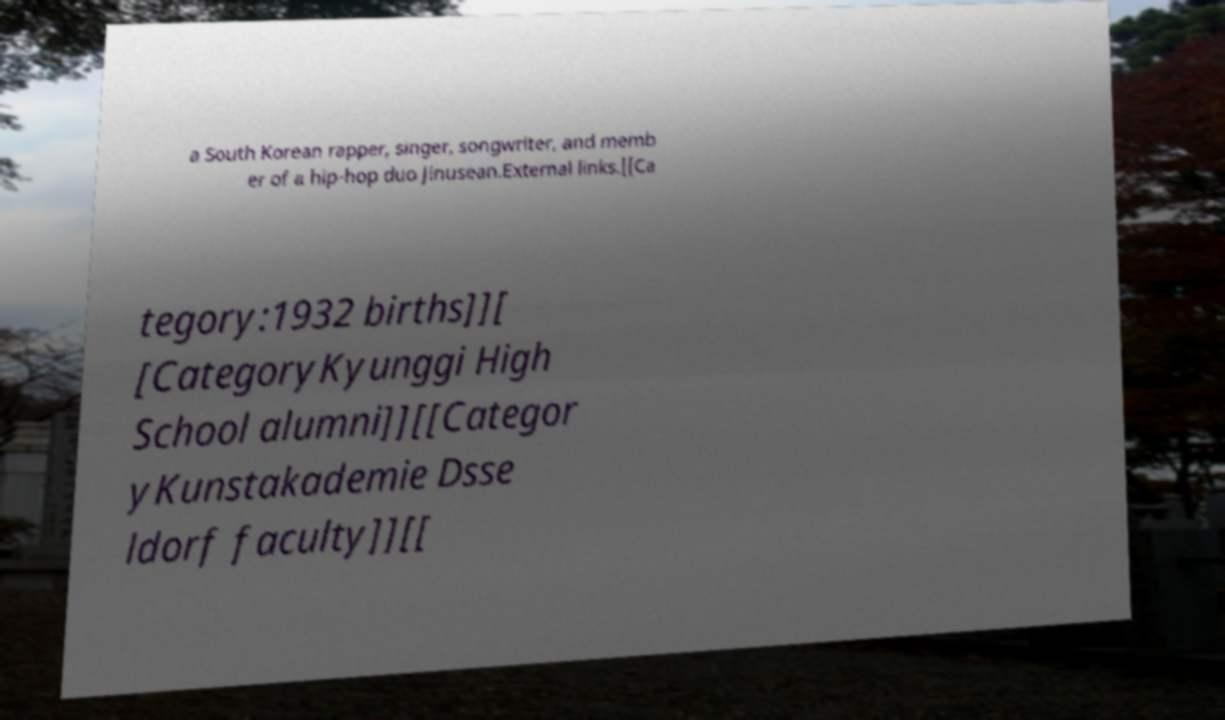I need the written content from this picture converted into text. Can you do that? a South Korean rapper, singer, songwriter, and memb er of a hip-hop duo Jinusean.External links.[[Ca tegory:1932 births]][ [CategoryKyunggi High School alumni]][[Categor yKunstakademie Dsse ldorf faculty]][[ 